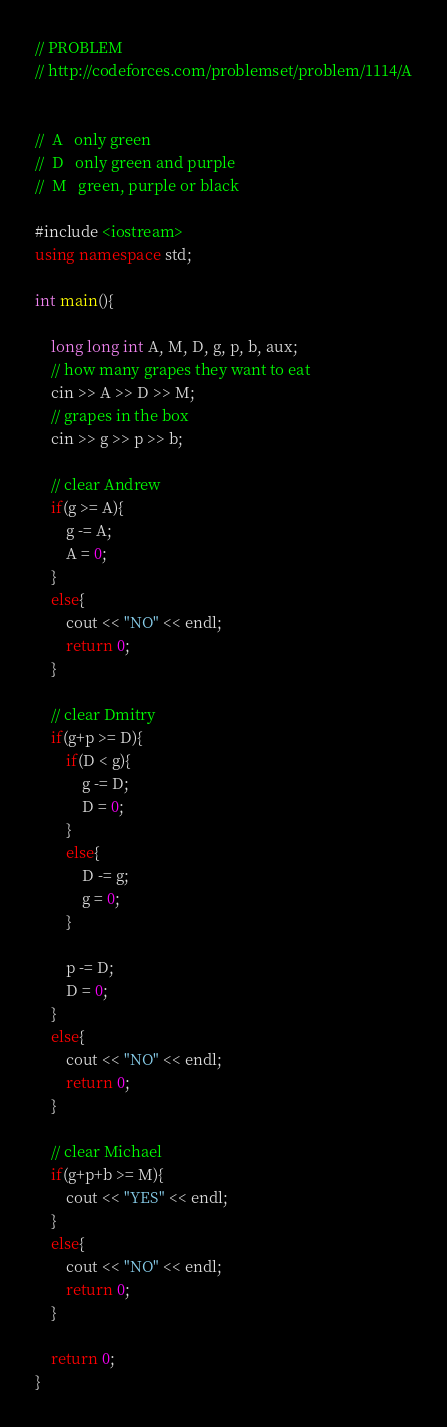<code> <loc_0><loc_0><loc_500><loc_500><_C++_>// PROBLEM
// http://codeforces.com/problemset/problem/1114/A


//	A	only green
//	D	only green and purple
//	M	green, purple or black

#include <iostream>
using namespace std; 

int main(){
	
	long long int A, M, D, g, p, b, aux;
	// how many grapes they want to eat
	cin >> A >> D >> M;
	// grapes in the box
	cin >> g >> p >> b;
	
	// clear Andrew
	if(g >= A){
		g -= A;
		A = 0;	
	}
	else{
		cout << "NO" << endl;
		return 0;
	}
	
	// clear Dmitry
	if(g+p >= D){
		if(D < g){
			g -= D;
			D = 0;
		}
		else{
			D -= g;
			g = 0;
		}
		
		p -= D;
		D = 0;
	}
	else{
		cout << "NO" << endl;
		return 0;
	}
	
	// clear Michael
	if(g+p+b >= M){
		cout << "YES" << endl;
	}
	else{
		cout << "NO" << endl;
		return 0;
	}
	
	return 0;
}

</code> 